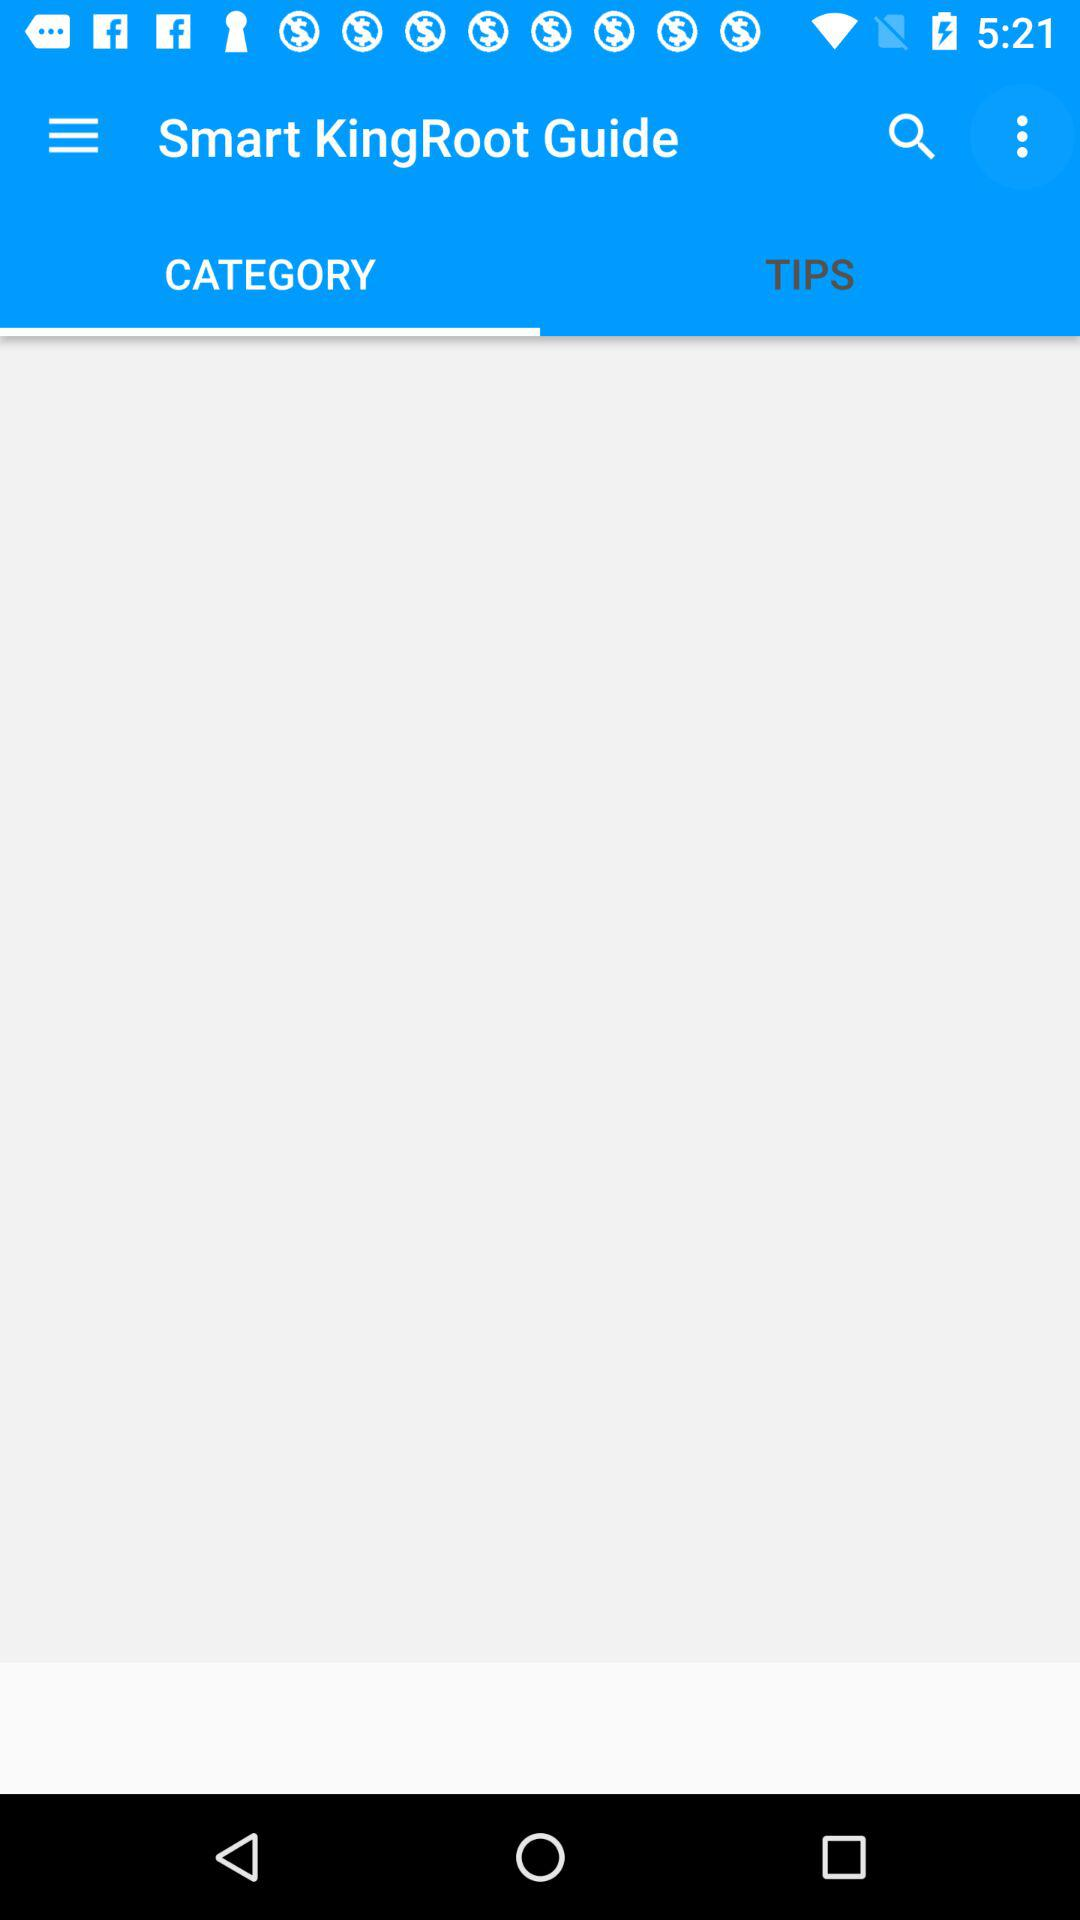What is the name of the application? The name of the application is "Smart KingRoot Guide". 